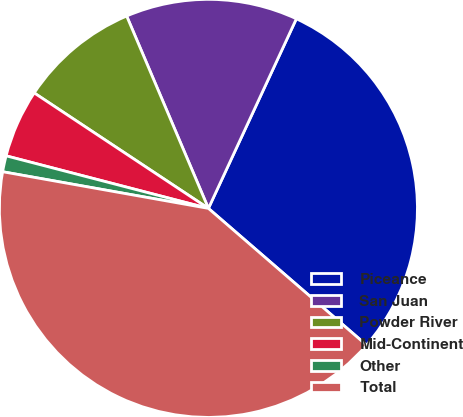Convert chart. <chart><loc_0><loc_0><loc_500><loc_500><pie_chart><fcel>Piceance<fcel>San Juan<fcel>Powder River<fcel>Mid-Continent<fcel>Other<fcel>Total<nl><fcel>29.44%<fcel>13.31%<fcel>9.29%<fcel>5.27%<fcel>1.24%<fcel>41.46%<nl></chart> 